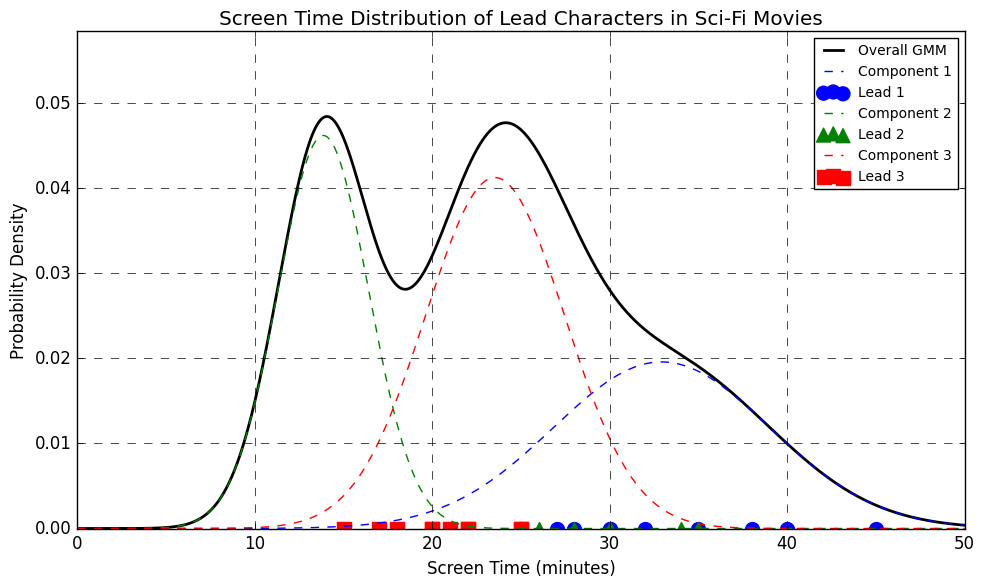What screen time corresponds to the peak probability density of the overall Gaussian Mixture Model (GMM)? To find the peak, check the highest point of the black line labeled 'Overall GMM' on the plot. The x-value at this highest point is the screen time.
Answer: Approximately 30 minutes Which lead character has the highest screen time in sci-fi movies according to the scatter points? Inspect the scatter points on the plot for each lead character color and marker; find which one has the highest x-position.
Answer: Lead 1 How many components are used in the Gaussian Mixture Model, and how are they visually differentiated? Components are indicated by the different dashed lines, each in a distinct color: blue, green, and red.
Answer: 3 components Which movie has the shortest screen time for Lead 3 and how can you tell? Look for the blue 'x' scatter points that represent Lead 3; identify the one with the smallest x-position.
Answer: Guardians of the Galaxy Which lead character has the smallest average screen time across the movies? Calculate the average screen time for each lead by averaging their respective scatter points' x-positions. The lead with the smallest average x-value is the answer.
Answer: Lead 4 How does the screen time of Lead 2 in 'Inception' compare with Lead 3 from the same movie? Locate the scatter points for 'Inception' and compare the x-positions for Lead 2 (brown triangles) and Lead 3 (blue squares).
Answer: Lead 2 has more screen time than Lead 3 Which lead character's screen time shows the largest spread (variance) across the movies? Analyze the scatter points; the lead with the widest range in x-values has the largest spread.
Answer: Lead 1 What is the total screen time for Lead 1 across all the movies? Sum up the x-values of the scatter points corresponding to Lead 1 across all movies.
Answer: 330 minutes In the figure, what role does the dashed lines in blue, green, and red play? These lines represent the individual probability densities of the components in the Gaussian Mixture Model, showing how each component contributes to the overall model.
Answer: They represent individual components of the GMM What can you infer from the height of the blue, green, and red dashed lines compared to the overall GMM curve? The heights of the dashed lines indicate the contribution of each component to the overall distribution. The combined effect of these dashed lines should align with the overall GMM curve.
Answer: They show each component's contribution to the overall model 